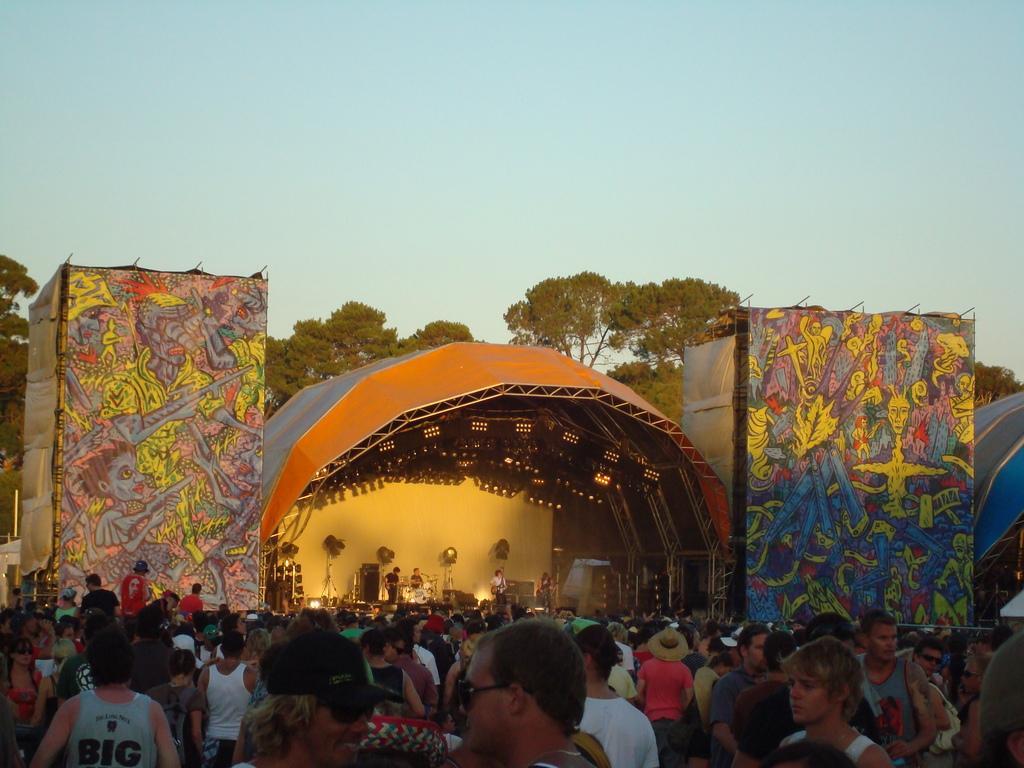How would you summarize this image in a sentence or two? In this image we can see persons standing on the dais and holding musical instruments in their hands. In the background there are trees, pictures on the clothes, persons standing on the ground and sky. 